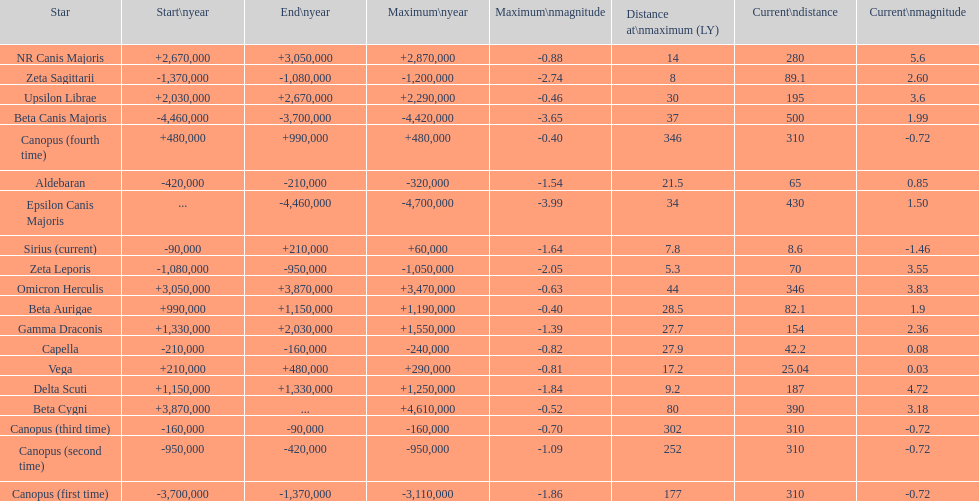What is the difference in the nearest current distance and farthest current distance? 491.4. 